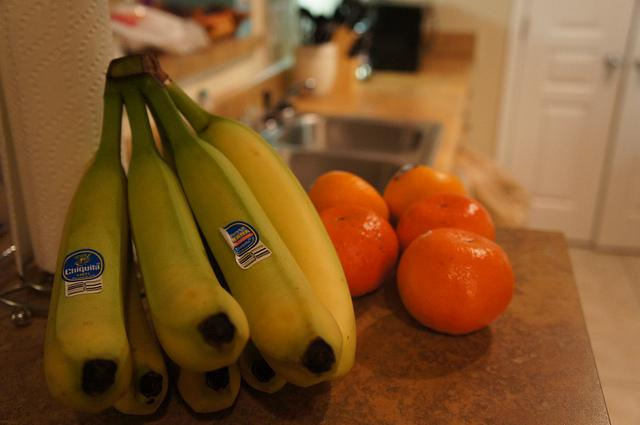What is next to the banana?

Choices:
A) fork
B) scimitar
C) machete
D) orange orange 